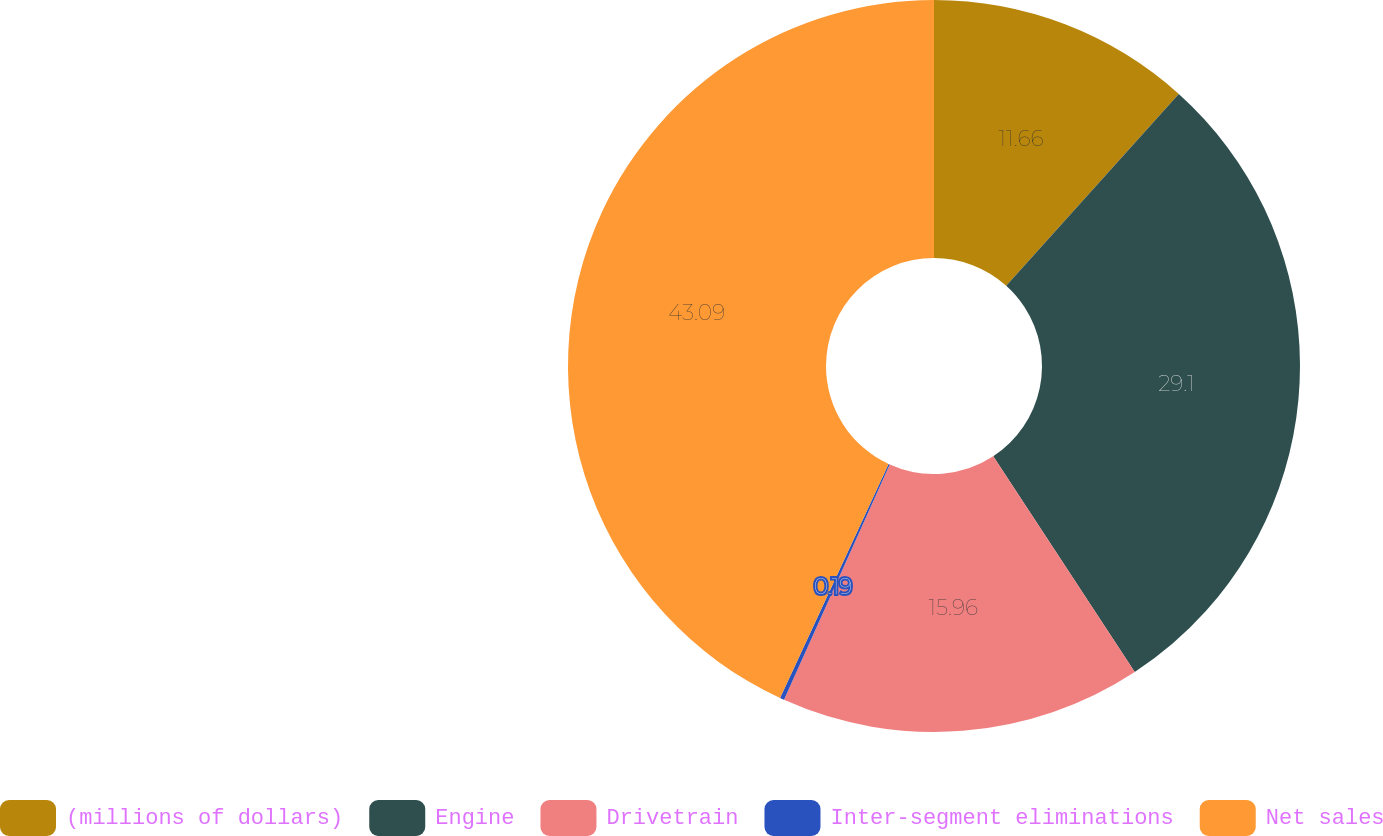<chart> <loc_0><loc_0><loc_500><loc_500><pie_chart><fcel>(millions of dollars)<fcel>Engine<fcel>Drivetrain<fcel>Inter-segment eliminations<fcel>Net sales<nl><fcel>11.66%<fcel>29.1%<fcel>15.96%<fcel>0.19%<fcel>43.09%<nl></chart> 